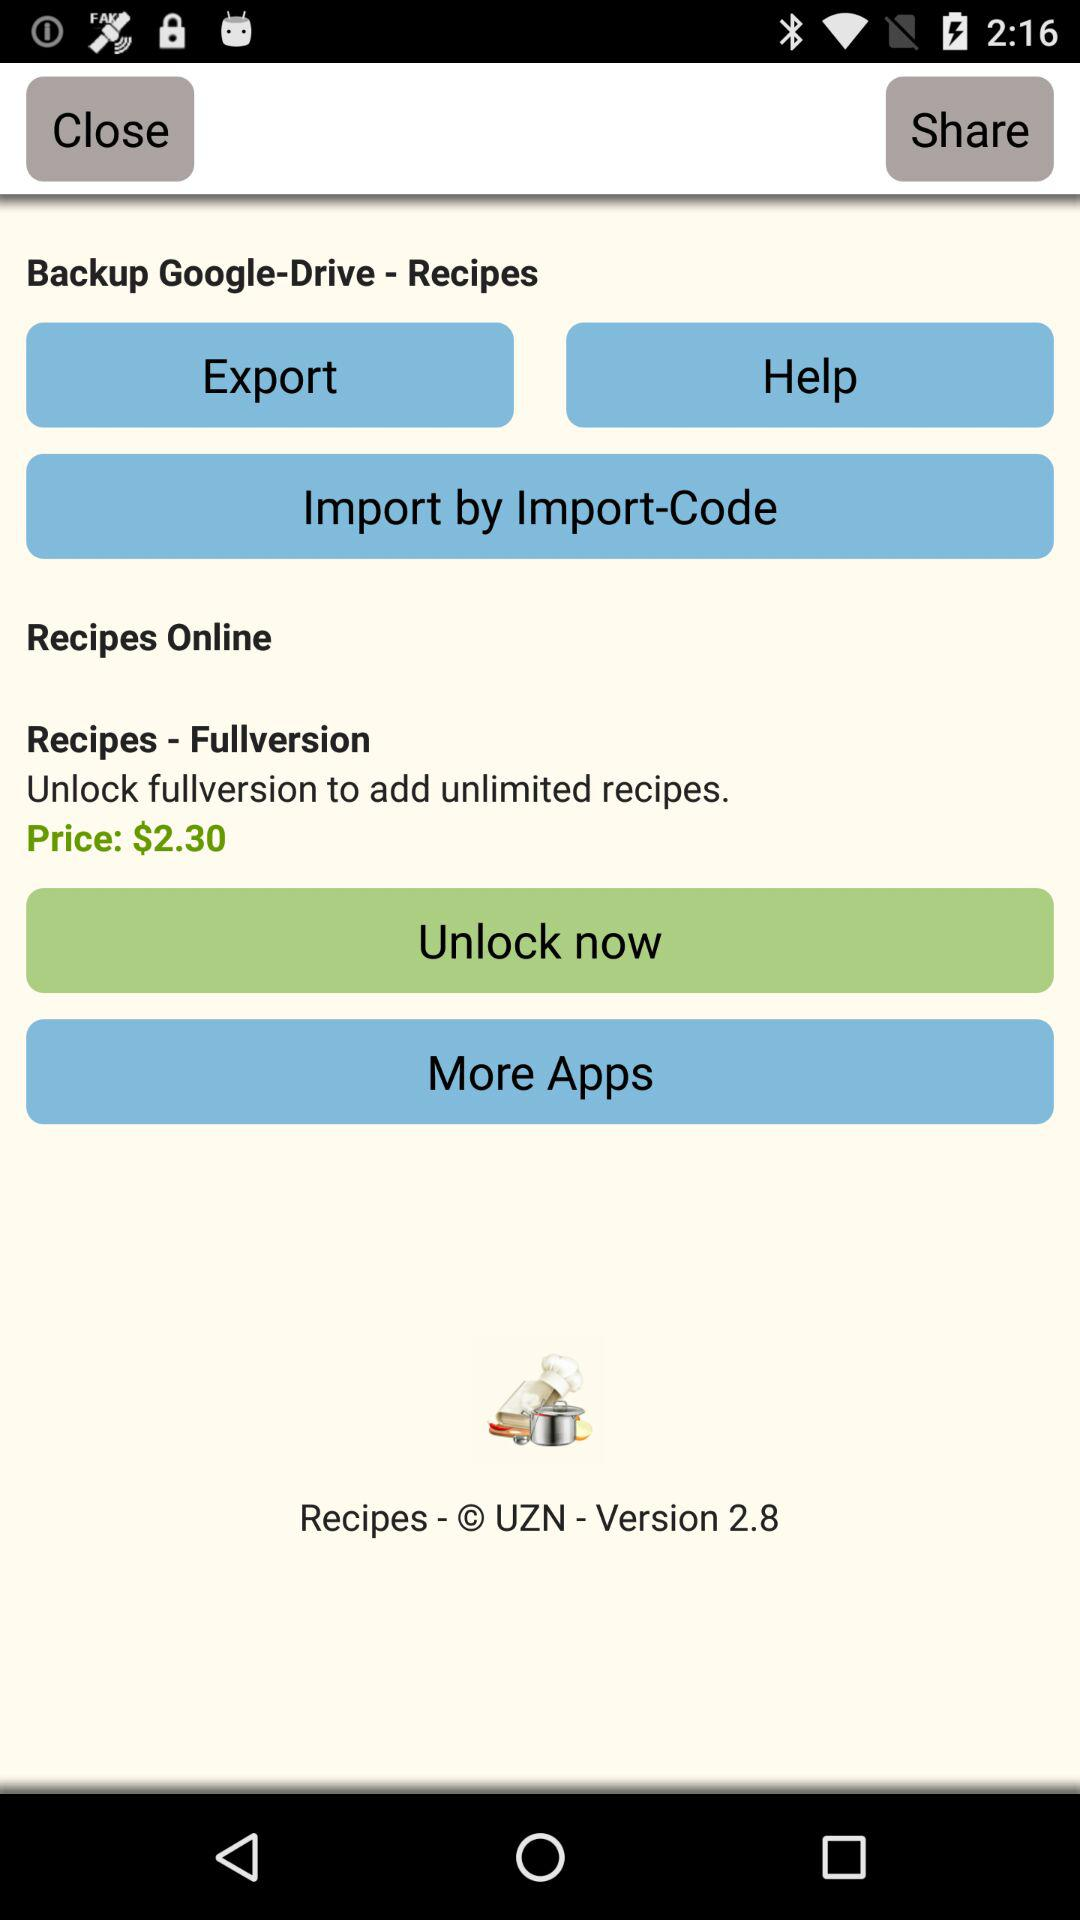What is the price for unlocking the full version for unlimited recipes? The price is $2.30. 